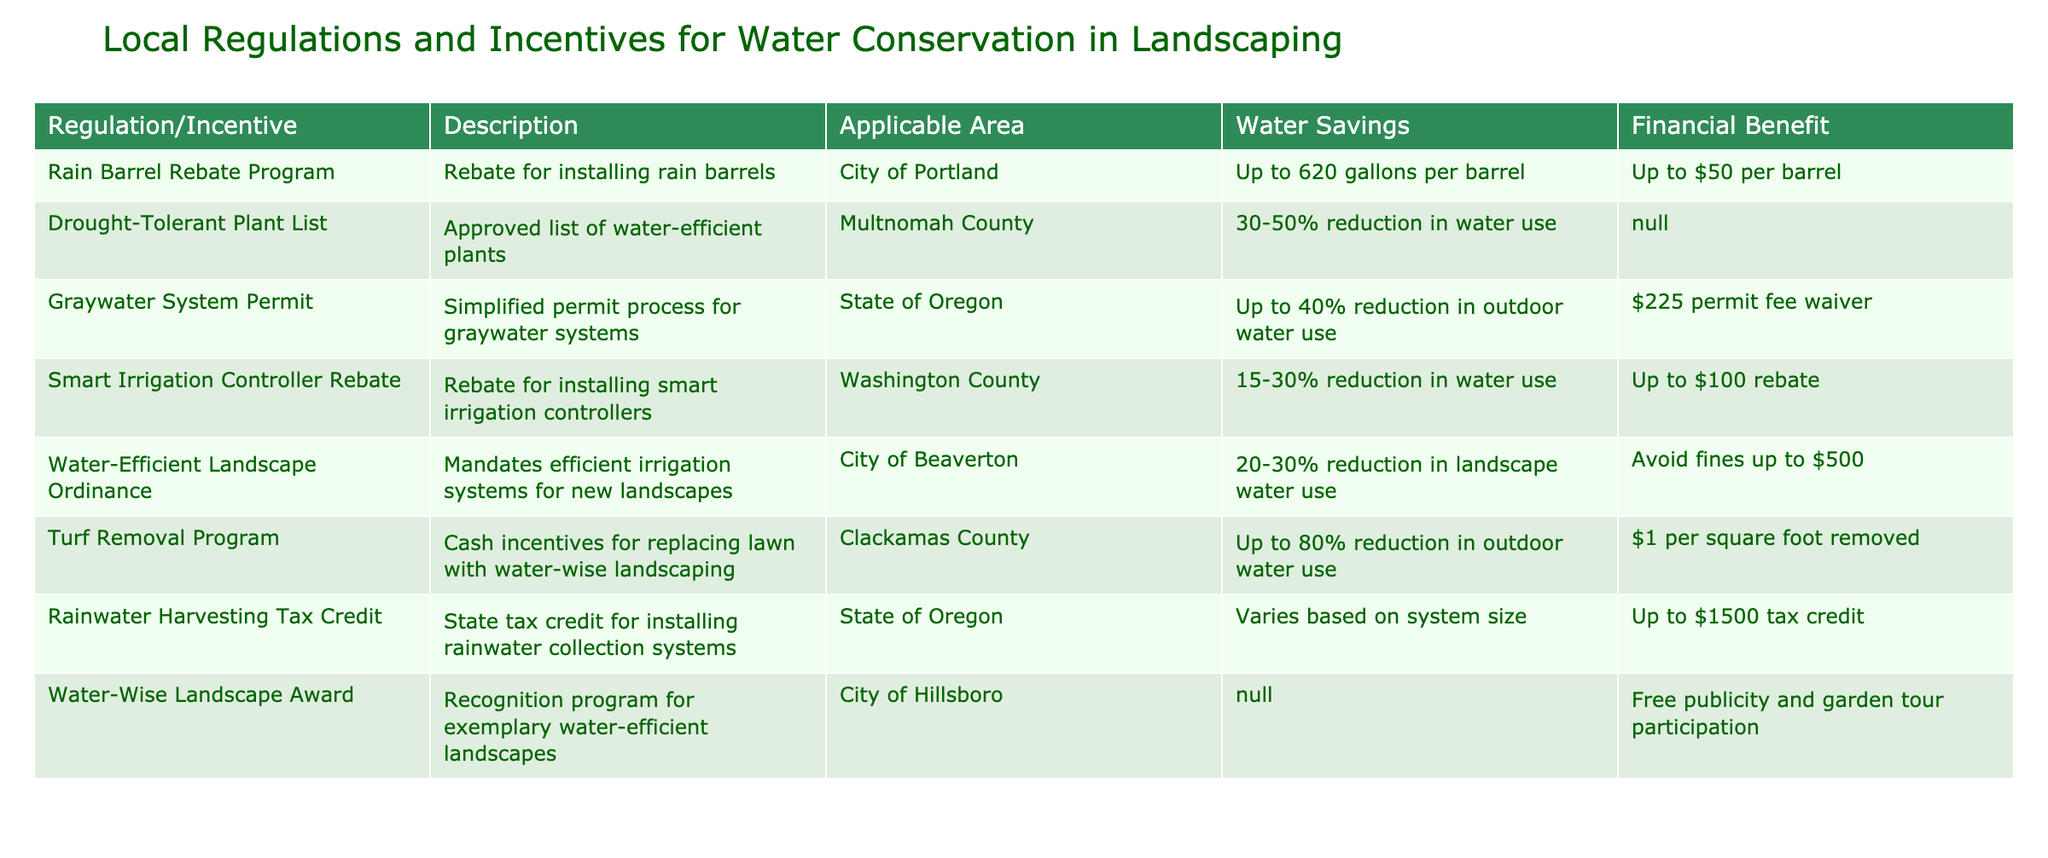What is the financial benefit of the Rain Barrel Rebate Program? The Rain Barrel Rebate Program offers a financial benefit of up to $50 per barrel. This is directly stated in the table under the Financial Benefit column for that regulation.
Answer: Up to $50 per barrel Which program offers the highest potential water savings? The Turf Removal Program offers up to an 80% reduction in outdoor water use, which is the highest value listed in the Water Savings column among all programs.
Answer: Up to 80% reduction in outdoor water use Is there a financial benefit for using the Drought-Tolerant Plant List? The table shows that the financial benefit for the Drought-Tolerant Plant List is listed as N/A, meaning there are no direct financial incentives provided for this program.
Answer: No What is the difference in water savings between the Smart Irrigation Controller Rebate and the Graywater System Permit? The Smart Irrigation Controller Rebate provides a water savings of 15-30% reduction, while the Graywater System Permit offers up to a 40% reduction. The difference is calculated by taking the maximum of the first (30%) and subtracting from the maximum of the second (40%), resulting in a difference of 10%.
Answer: 10% How many programs provide cash incentives? By reviewing the table, we find that there are two programs listed with financial incentives: the Turf Removal Program and the Rain Barrel Rebate Program. Thus, the count is 2.
Answer: 2 Which area is eligible for the Graywater System Permit? The table states that the Graywater System Permit is applicable in the State of Oregon, which is specifically mentioned in the Applicable Area column.
Answer: State of Oregon What would be the total financial benefit of removing 500 square feet of turf under the Turf Removal Program? The financial benefit for the Turf Removal Program is $1 per square foot removed. Therefore, for 500 square feet, the total benefit is 500 * 1 = $500. This is calculated by multiplying the square footage by the incentive amount.
Answer: $500 Is the Water-Wise Landscape Award associated with any financial incentives? According to the table, the Water-Wise Landscape Award does not provide any financial incentive as indicated by the N/A designation under the Financial Benefit column.
Answer: No 